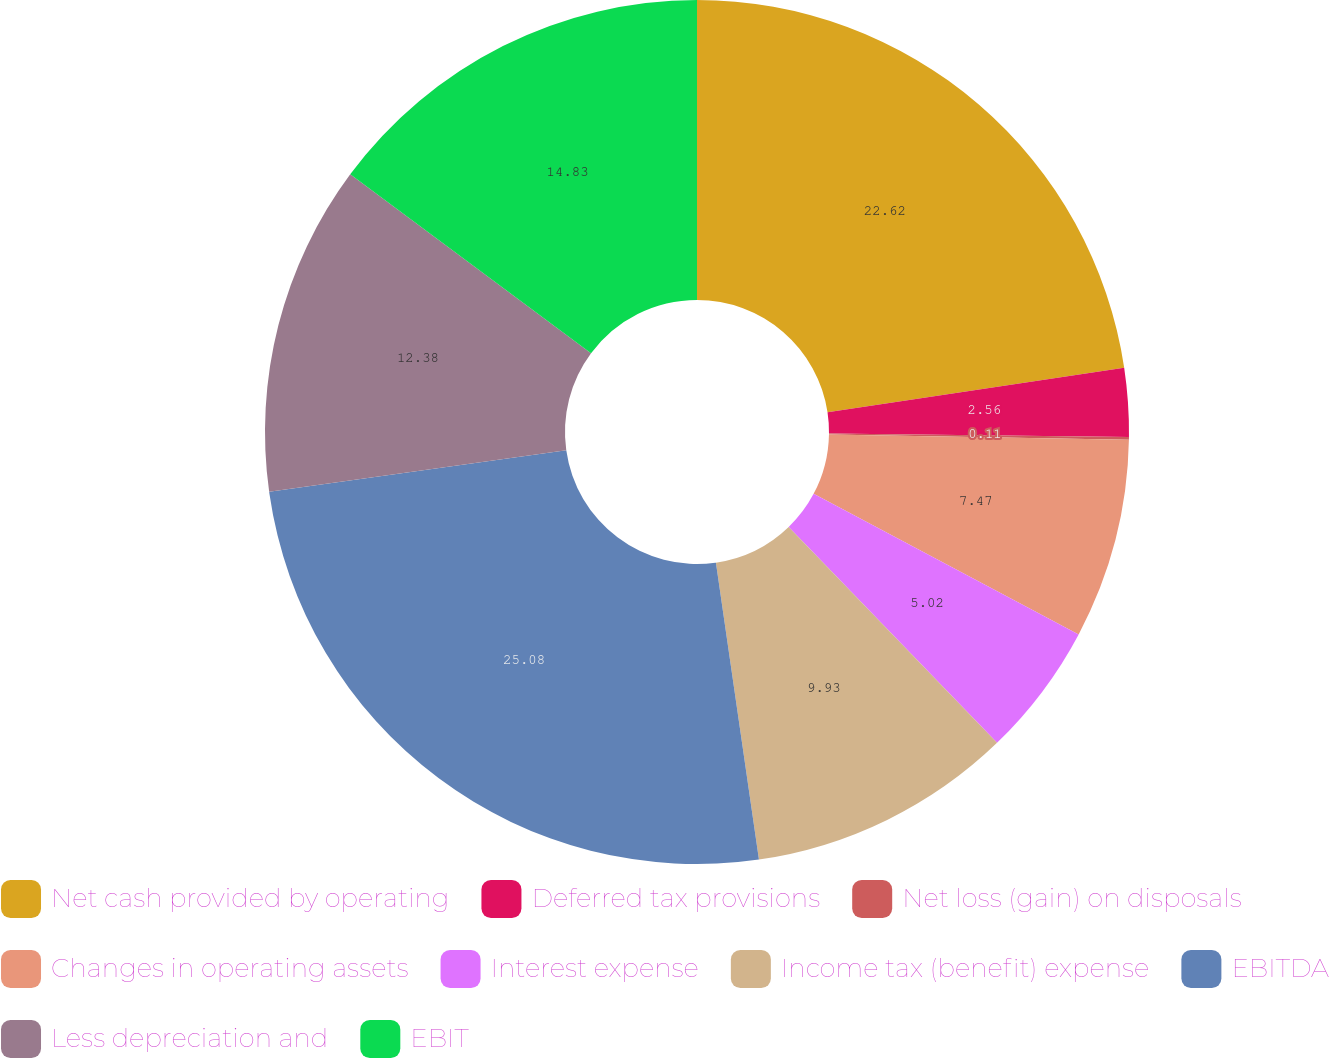<chart> <loc_0><loc_0><loc_500><loc_500><pie_chart><fcel>Net cash provided by operating<fcel>Deferred tax provisions<fcel>Net loss (gain) on disposals<fcel>Changes in operating assets<fcel>Interest expense<fcel>Income tax (benefit) expense<fcel>EBITDA<fcel>Less depreciation and<fcel>EBIT<nl><fcel>22.62%<fcel>2.56%<fcel>0.11%<fcel>7.47%<fcel>5.02%<fcel>9.93%<fcel>25.08%<fcel>12.38%<fcel>14.83%<nl></chart> 